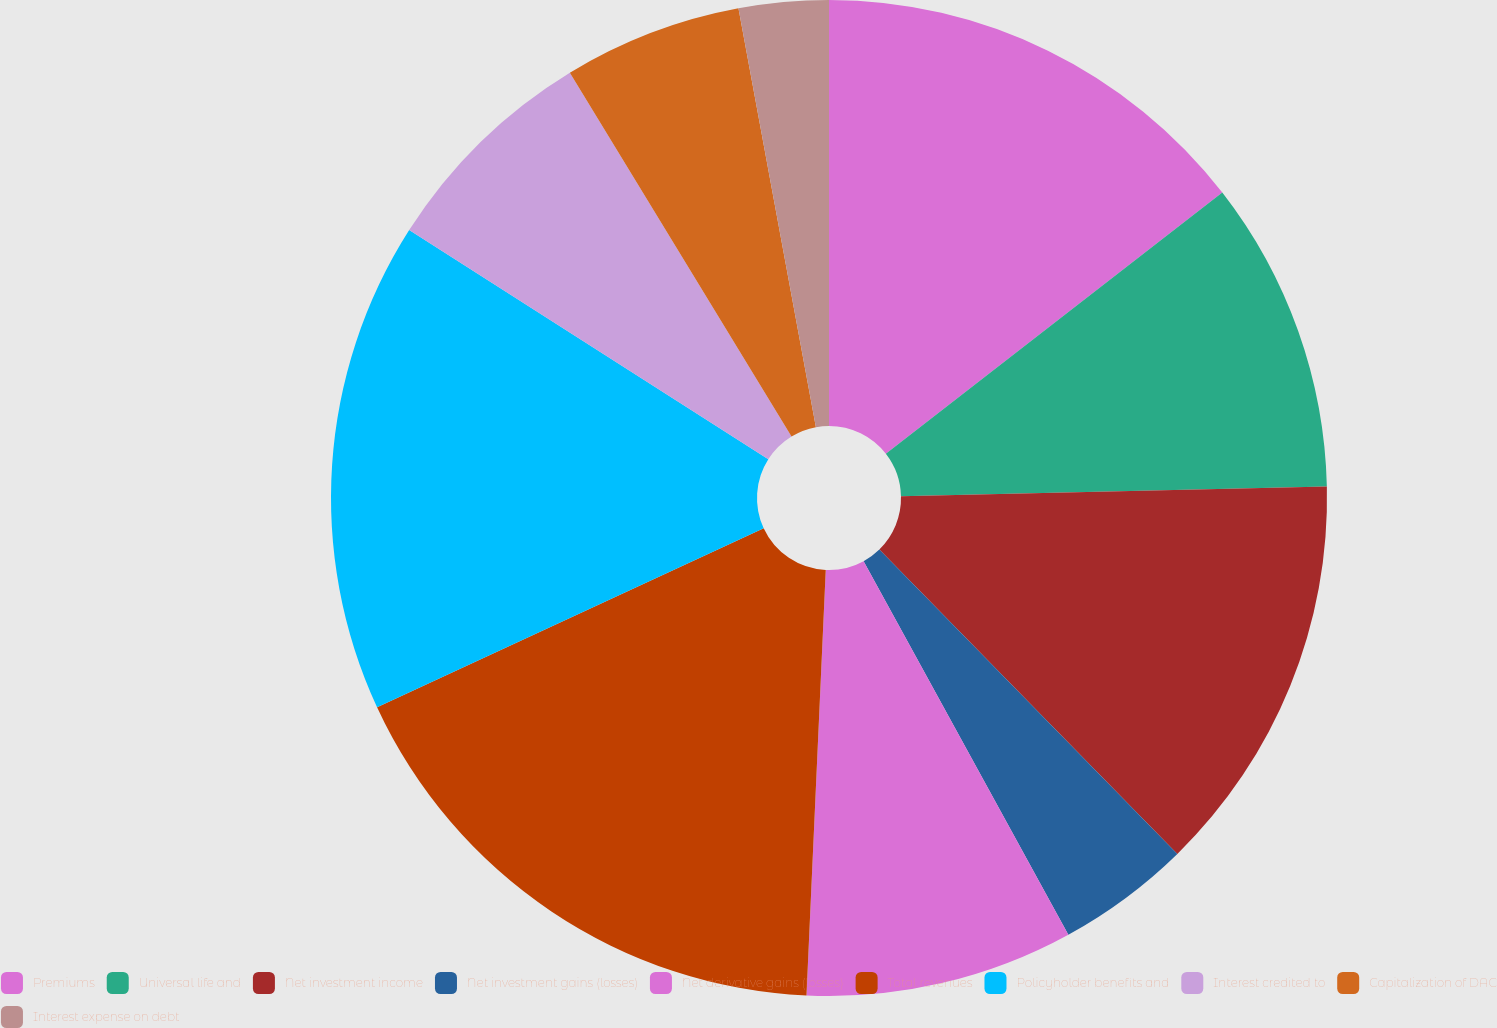<chart> <loc_0><loc_0><loc_500><loc_500><pie_chart><fcel>Premiums<fcel>Universal life and<fcel>Net investment income<fcel>Net investment gains (losses)<fcel>Net derivative gains (losses)<fcel>Total revenues<fcel>Policyholder benefits and<fcel>Interest credited to<fcel>Capitalization of DAC<fcel>Interest expense on debt<nl><fcel>14.49%<fcel>10.14%<fcel>13.04%<fcel>4.35%<fcel>8.7%<fcel>17.38%<fcel>15.94%<fcel>7.25%<fcel>5.8%<fcel>2.91%<nl></chart> 